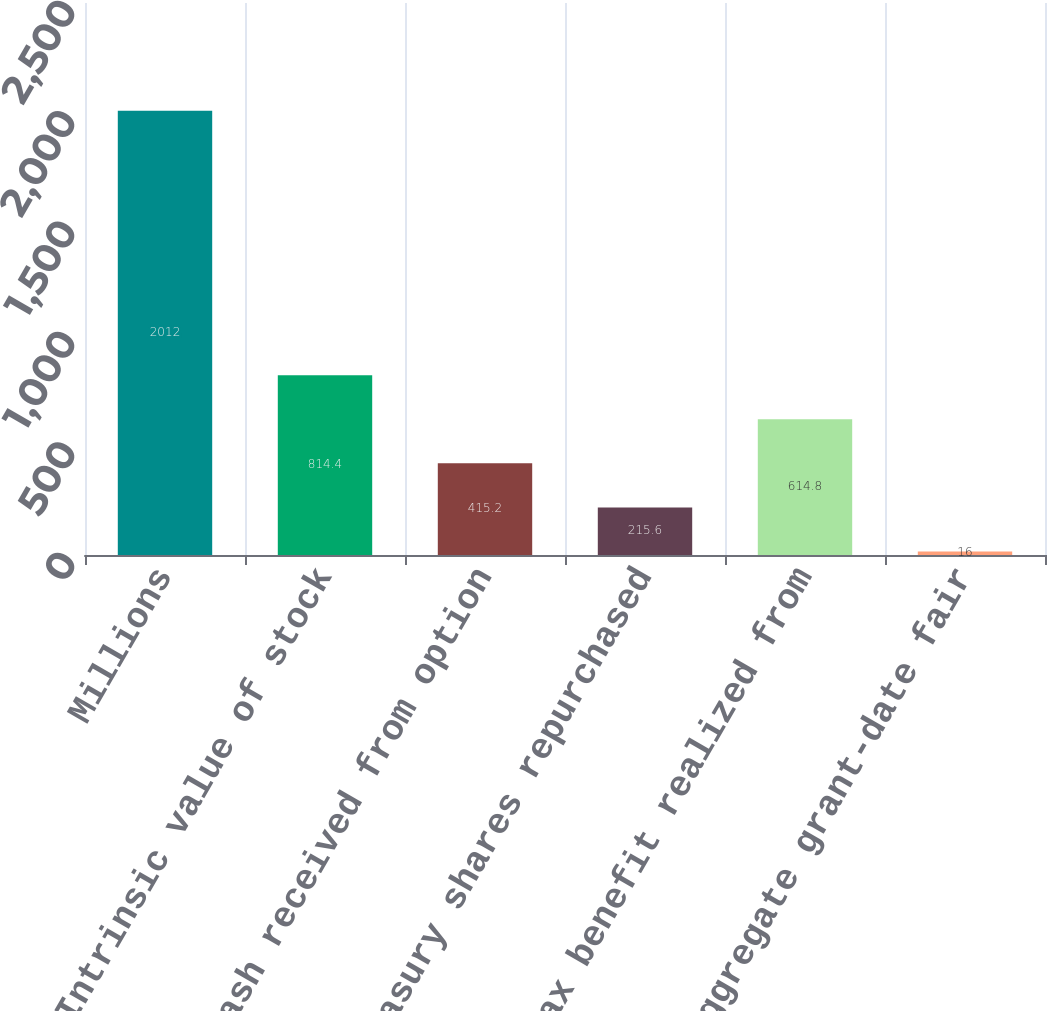Convert chart. <chart><loc_0><loc_0><loc_500><loc_500><bar_chart><fcel>Millions<fcel>Intrinsic value of stock<fcel>Cash received from option<fcel>Treasury shares repurchased<fcel>Tax benefit realized from<fcel>Aggregate grant-date fair<nl><fcel>2012<fcel>814.4<fcel>415.2<fcel>215.6<fcel>614.8<fcel>16<nl></chart> 